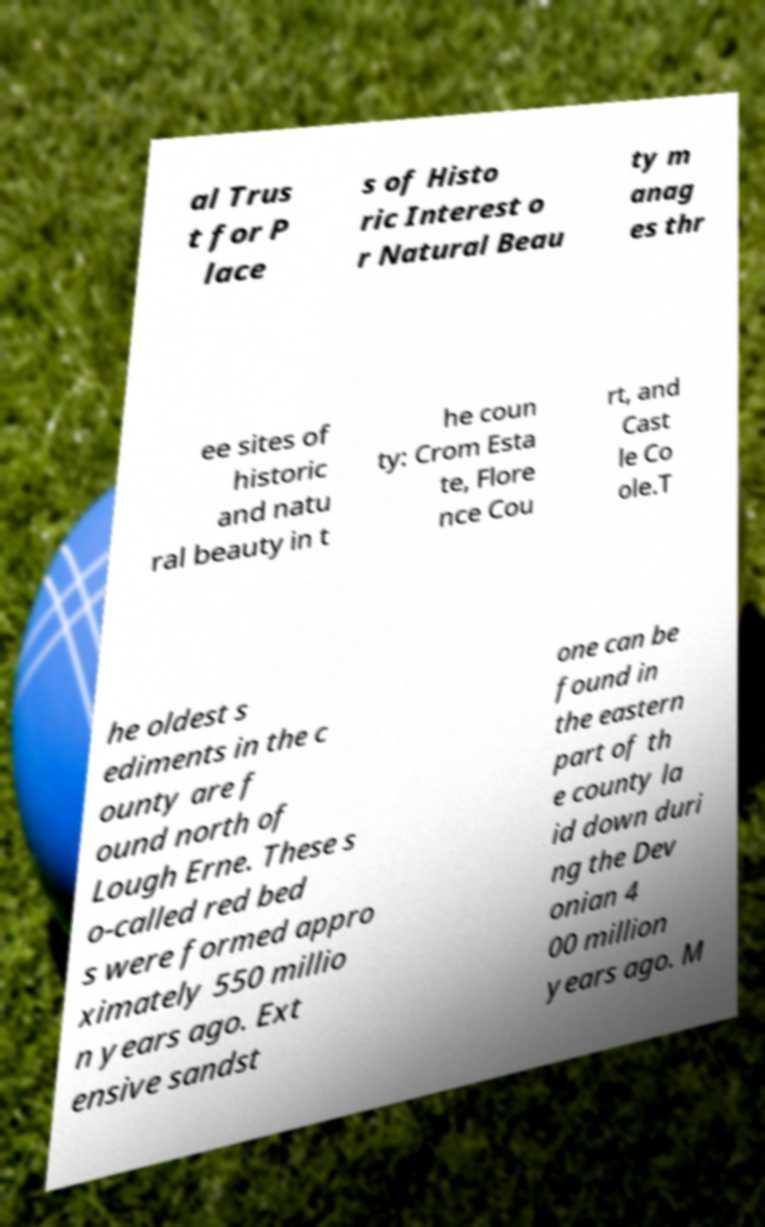Can you read and provide the text displayed in the image?This photo seems to have some interesting text. Can you extract and type it out for me? al Trus t for P lace s of Histo ric Interest o r Natural Beau ty m anag es thr ee sites of historic and natu ral beauty in t he coun ty: Crom Esta te, Flore nce Cou rt, and Cast le Co ole.T he oldest s ediments in the c ounty are f ound north of Lough Erne. These s o-called red bed s were formed appro ximately 550 millio n years ago. Ext ensive sandst one can be found in the eastern part of th e county la id down duri ng the Dev onian 4 00 million years ago. M 